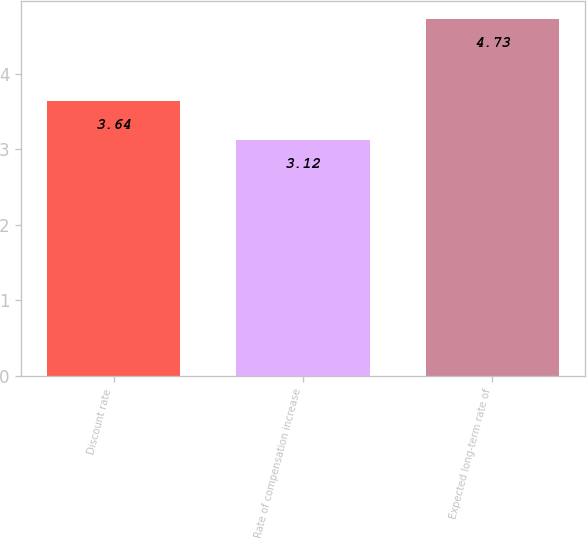Convert chart. <chart><loc_0><loc_0><loc_500><loc_500><bar_chart><fcel>Discount rate<fcel>Rate of compensation increase<fcel>Expected long-term rate of<nl><fcel>3.64<fcel>3.12<fcel>4.73<nl></chart> 